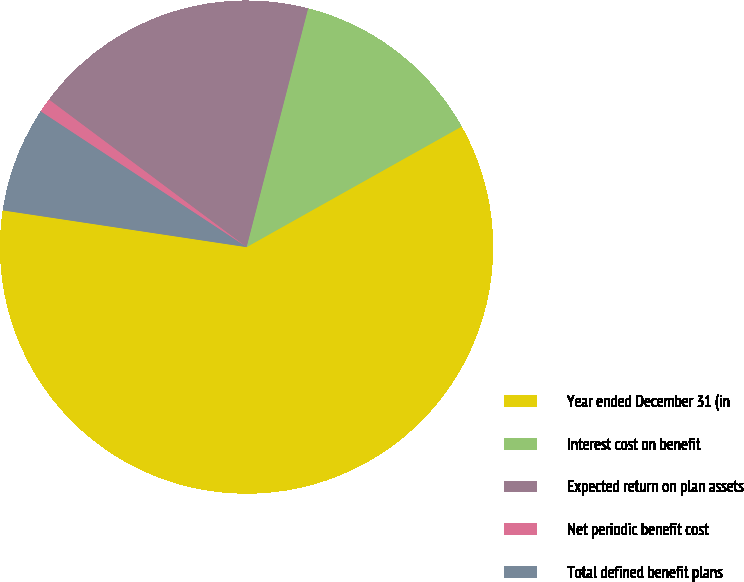Convert chart to OTSL. <chart><loc_0><loc_0><loc_500><loc_500><pie_chart><fcel>Year ended December 31 (in<fcel>Interest cost on benefit<fcel>Expected return on plan assets<fcel>Net periodic benefit cost<fcel>Total defined benefit plans<nl><fcel>60.51%<fcel>12.85%<fcel>18.81%<fcel>0.93%<fcel>6.89%<nl></chart> 